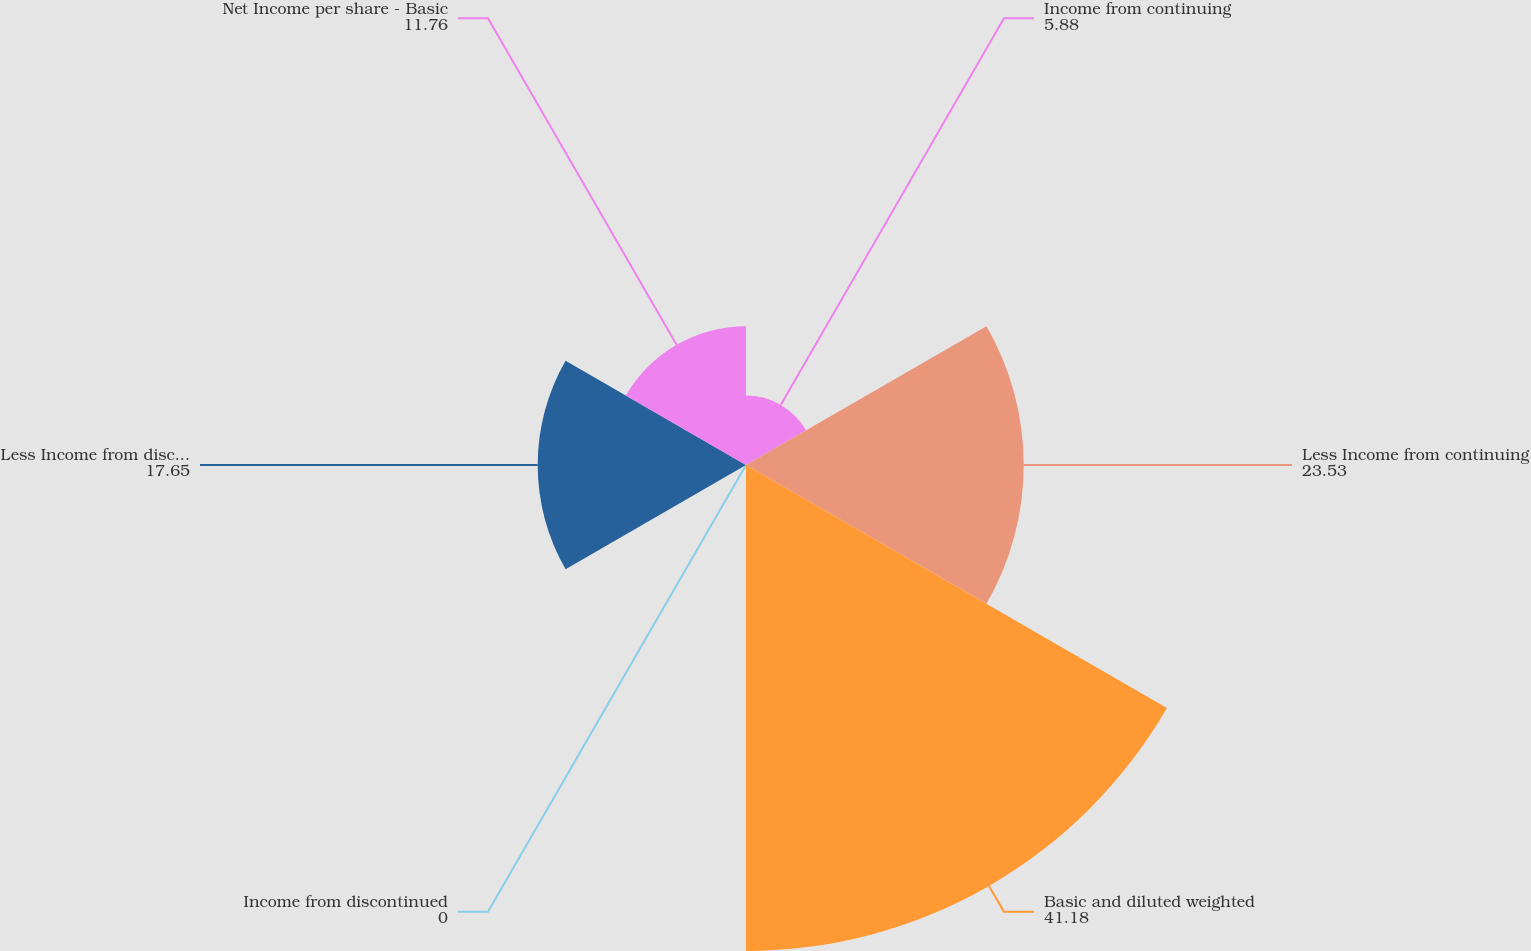Convert chart to OTSL. <chart><loc_0><loc_0><loc_500><loc_500><pie_chart><fcel>Income from continuing<fcel>Less Income from continuing<fcel>Basic and diluted weighted<fcel>Income from discontinued<fcel>Less Income from discontinued<fcel>Net Income per share - Basic<nl><fcel>5.88%<fcel>23.53%<fcel>41.18%<fcel>0.0%<fcel>17.65%<fcel>11.76%<nl></chart> 